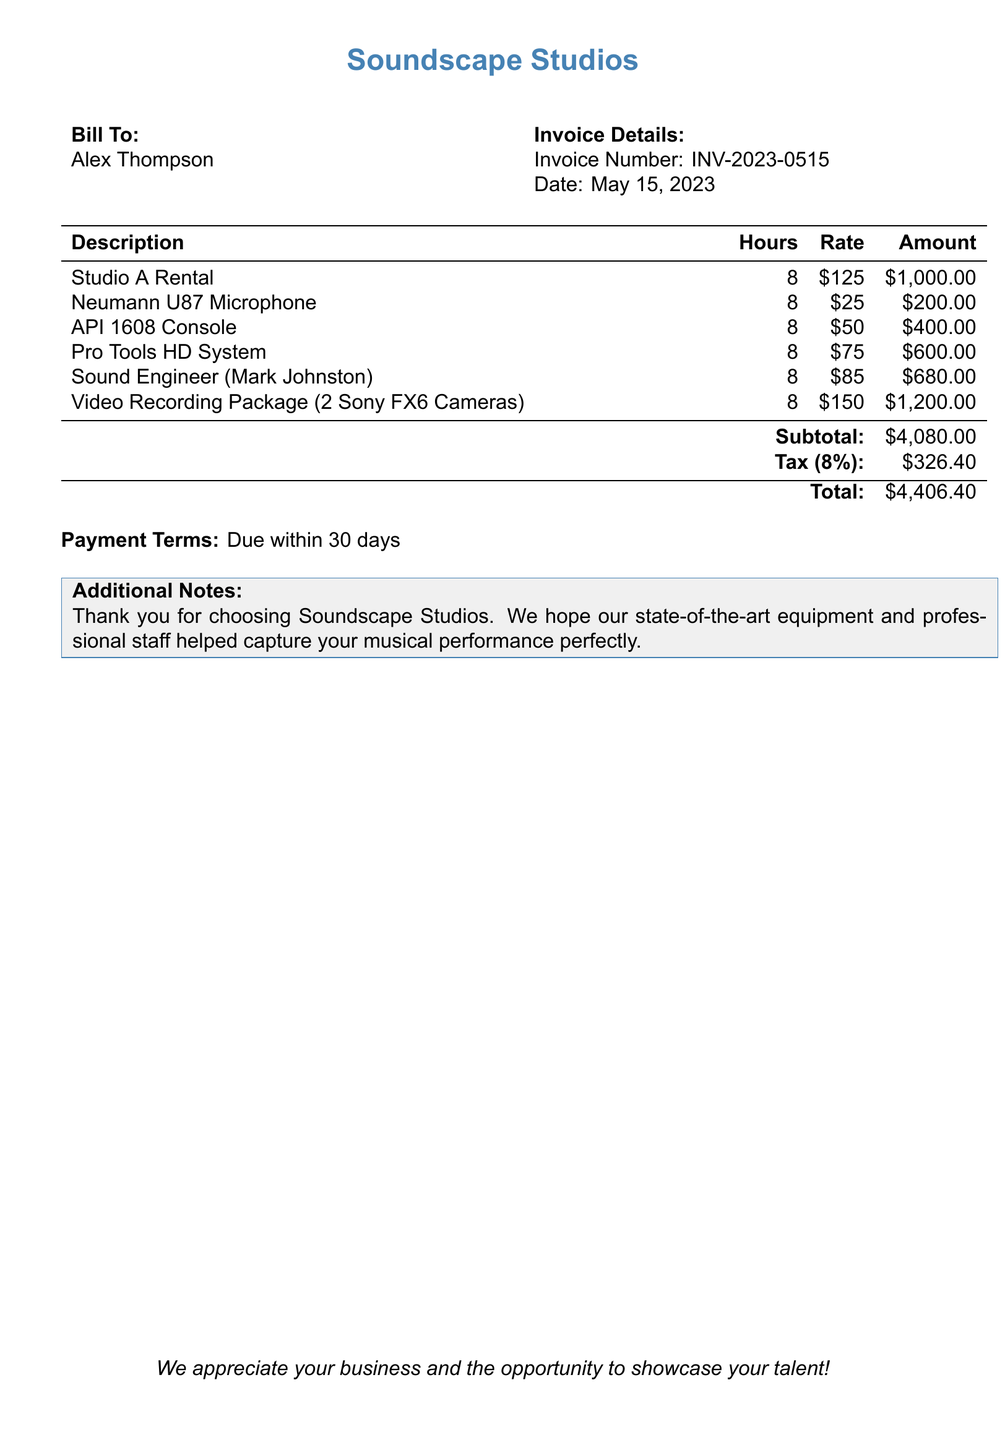What is the invoice number? The invoice number is listed in the invoice details section of the document.
Answer: INV-2023-0515 What is the date of the invoice? The date is specified in the invoice details section of the document.
Answer: May 15, 2023 How many hours were recorded for the studio rental? The hours recorded for studio rental are stated in the itemized list of services.
Answer: 8 What is the subtotal amount? The subtotal is calculated from the total of all itemized services before tax.
Answer: $4,080.00 What is the tax rate applied to the bill? The tax rate is mentioned in the subtotal section of the document.
Answer: 8% Who was the sound engineer for this session? The name of the sound engineer is provided in the itemized services list.
Answer: Mark Johnston What is the total amount due? The total amount due is calculated after adding tax to the subtotal.
Answer: $4,406.40 How much is charged for the video recording package? The amount charged for the video recording package is listed in the itemized services.
Answer: $1,200.00 What are the payment terms for this invoice? The payment terms are detailed at the end of the document.
Answer: Due within 30 days 